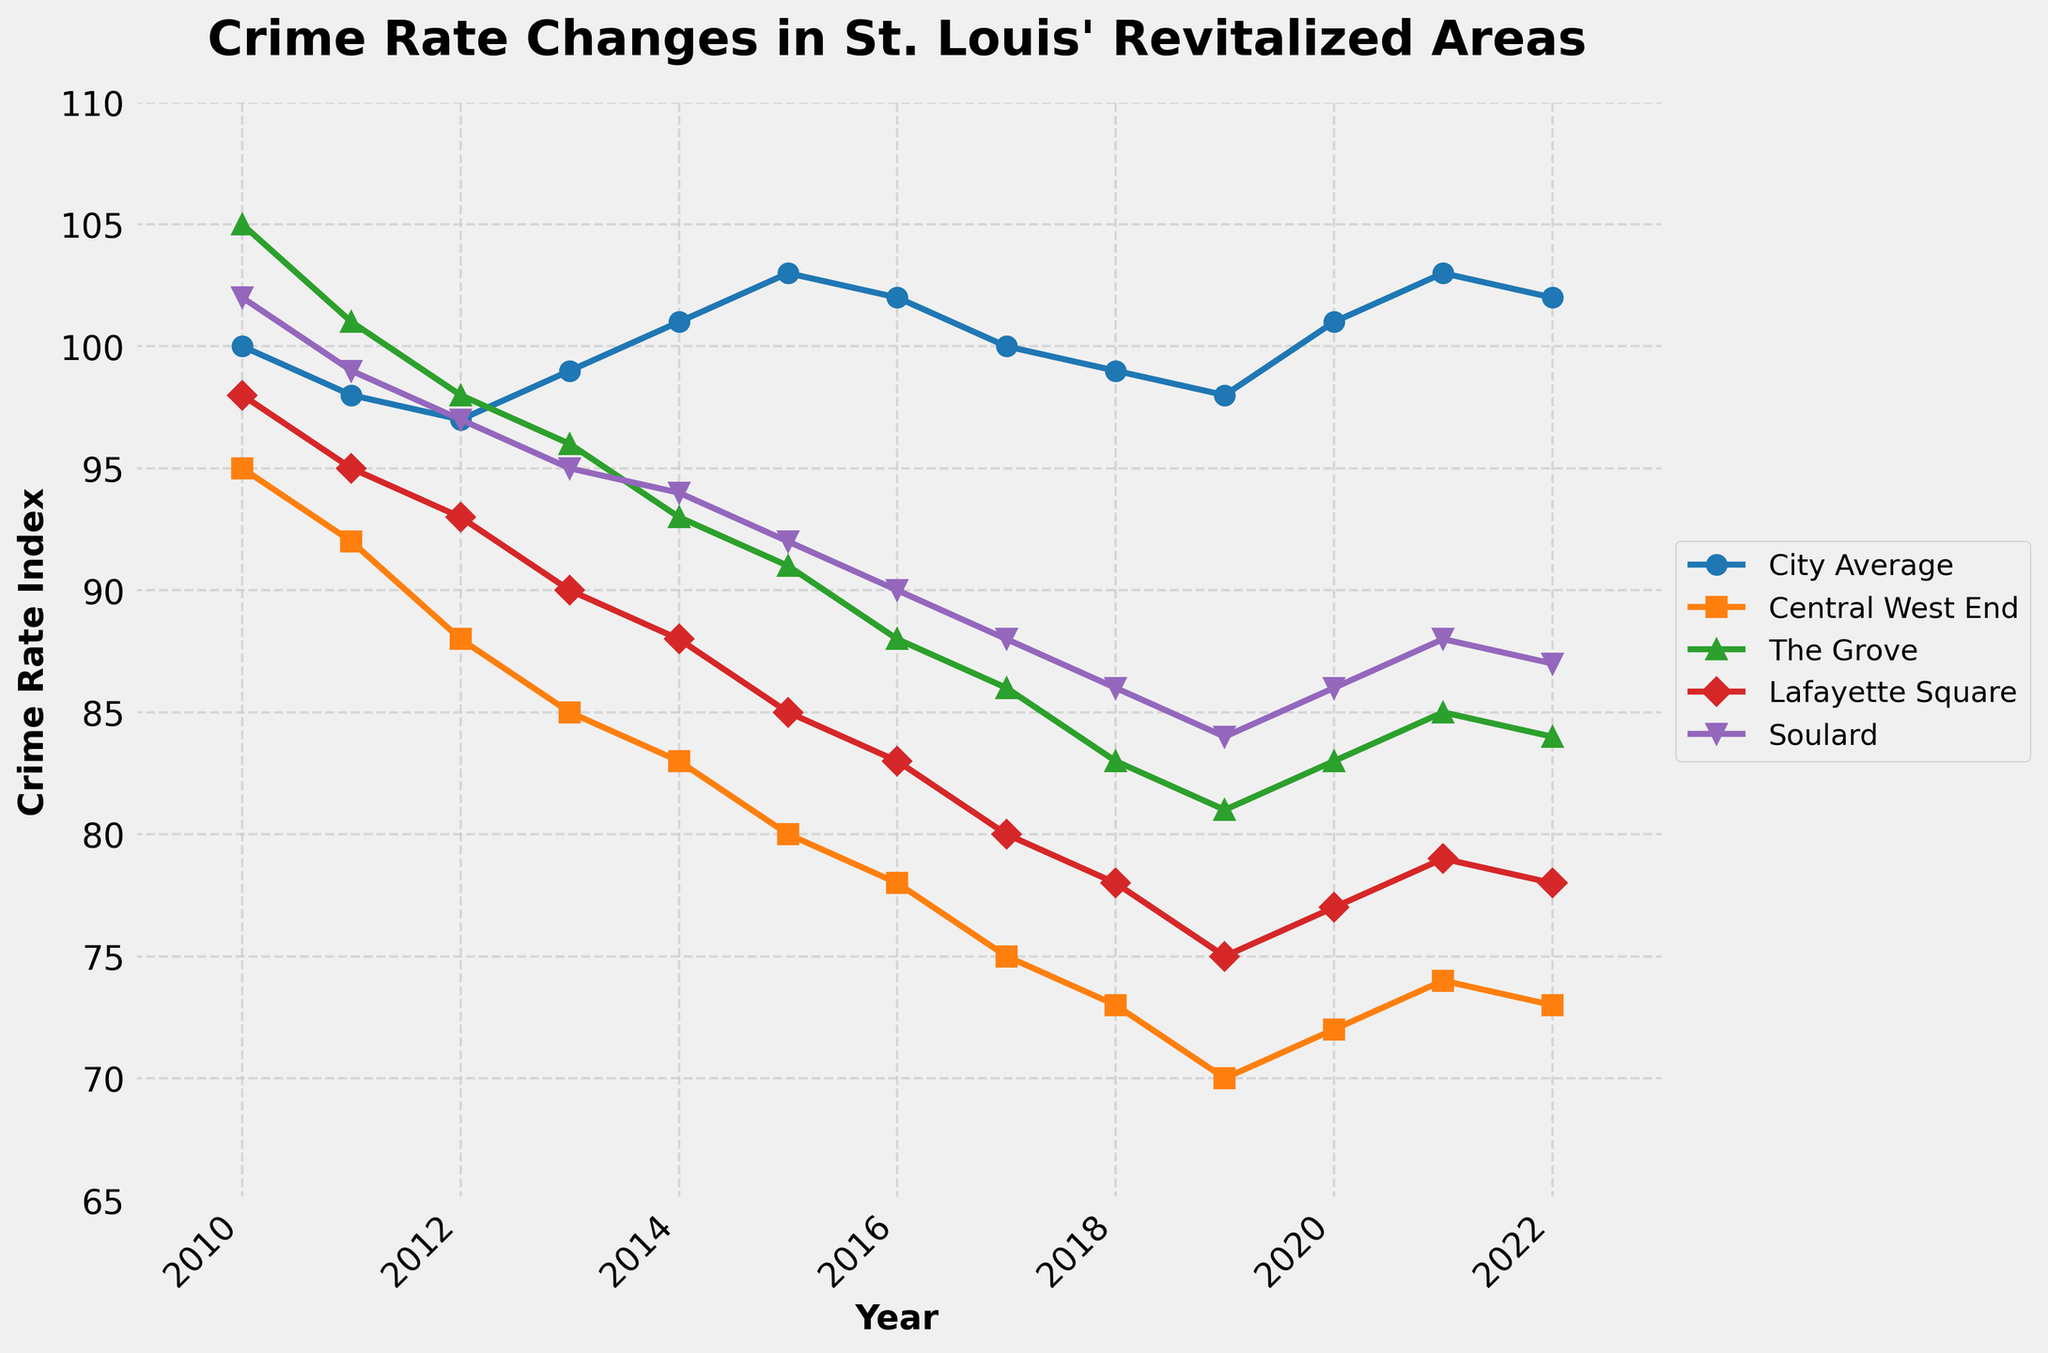What's the overall trend in the crime rate for Central West End from 2010 to 2022? The trend can be observed by tracking the plotted line for Central West End from 2010 to 2022. The line consistently decreases over the years.
Answer: Decreasing In which year was the crime rate the highest in Soulard? Check the plotted line for Soulard. The highest point on this line occurs in 2010.
Answer: 2010 By how much did the crime rate in The Grove decrease from 2010 to 2022? Subtract the crime rate of The Grove in 2022 from its crime rate in 2010. The values are 105 (2010) and 84 (2022). 105 - 84 = 21.
Answer: 21 Which revitalized area had the lowest crime rate in 2022? Compare the end points of each plotted line in 2022. Central West End has the lowest point.
Answer: Central West End How does the average crime rate of the revitalized areas in 2022 compare to the city average in the same year? Calculate the average crime rate of Central West End, The Grove, Lafayette Square, and Soulard in 2022. Their values are 73, 84, 78, and 87 respectively. Average = (73 + 84 + 78 + 87) / 4 = 80.5. Compare this value to the city average in 2022, which is 102.
Answer: Lower Between which years did Lafayette Square see the steepest decline in its crime rate? Find the segment where the plotted line for Lafayette Square has the steepest negative slope. Between 2010 (98) and 2017 (80), the decline is 18, the steepest of any segment.
Answer: 2010-2017 What is the difference between the crime rate of Soulard and the city average in 2020? Subtract the crime rate of Soulard from the city average in 2020. The values are 86 (Soulard) and 101 (city average). 101 - 86 = 15.
Answer: 15 Which area showed the most consistent decrease in crime rate over the observed years? Look for the most linear downward trend among the plotted lines. Central West End consistently decreases every year.
Answer: Central West End What is the general trend of the city average crime rate from 2010 to 2022? Track the city average line from 2010 to 2022. It initially decreases, slightly increases around 2015-2017, and then stabilizes with minor fluctuations.
Answer: Slight decrease/stable In 2015, how does the crime rate in The Grove compare to that in Lafayette Square? Check the plotted values for The Grove and Lafayette Square in 2015. The Grove is at 91, while Lafayette Square is at 85.
Answer: Higher 